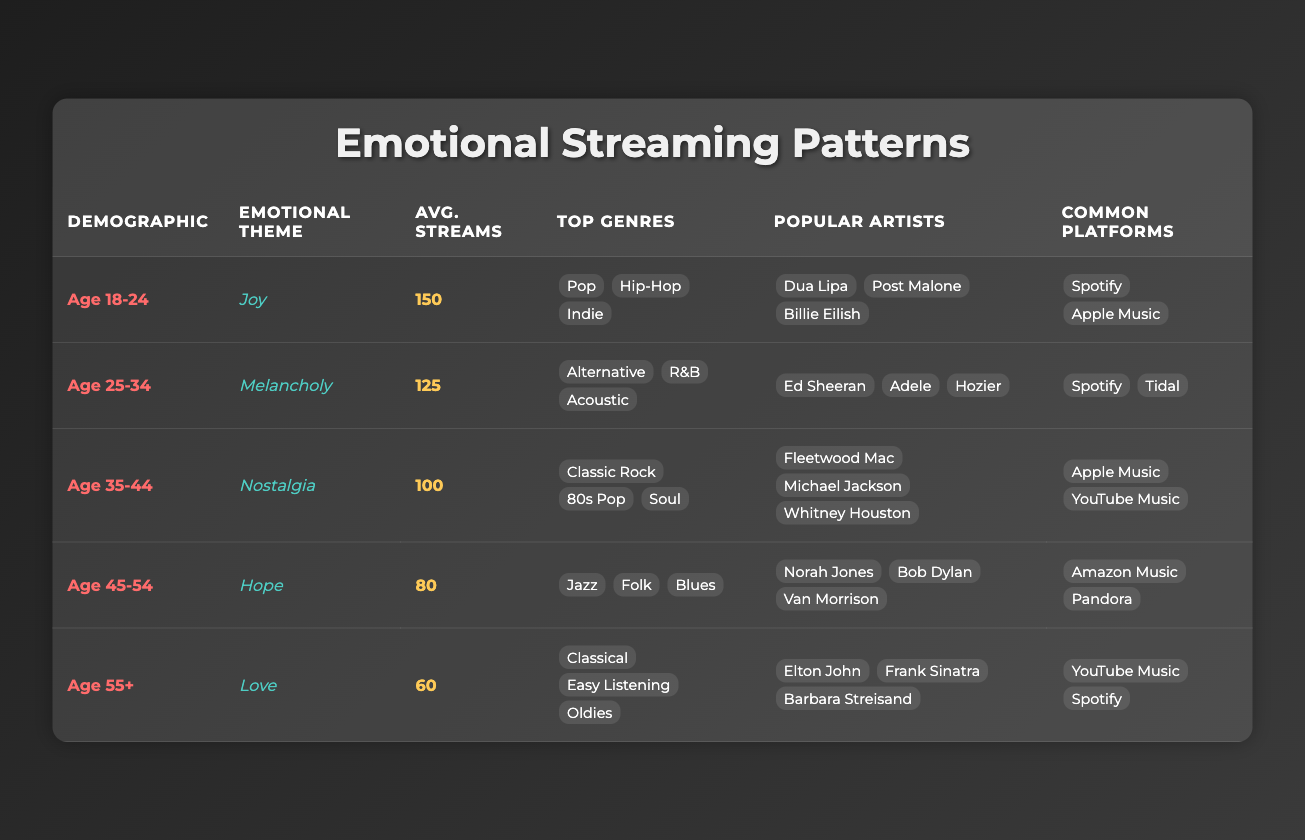What is the emotional theme for the Age 35-44 demographic group? The table clearly states that the emotional theme for the Age 35-44 demographic group is "Nostalgia."
Answer: Nostalgia Which demographic group has the highest average streams per user? By examining the averages listed in the table, the Age 18-24 demographic group has the highest average streams per user at 150.
Answer: Age 18-24 Is the top genre for the Age 45-54 demographic group Jazz? The table indicates that the top genres for this demographic group include Jazz, but there are also Folk and Blues listed. Hence, the answer is yes, as Jazz is one of the top genres.
Answer: Yes Calculate the average streams per user for all demographic groups combined. The average streams per user can be calculated by summing up the average streams from all groups: 150 + 125 + 100 + 80 + 60 = 615. There are 5 demographic groups, so the average is 615 / 5 = 123.
Answer: 123 Which emotional theme corresponds with Age 55+? The table specifies that the emotional theme for the Age 55+ demographic group is "Love."
Answer: Love Do the common platforms for Age 25-34 include Apple Music? The common platforms listed for Age 25-34 are Spotify and Tidal, which does not include Apple Music. Therefore, the answer is no.
Answer: No How many top genres are listed for the Age 18-24 demographic group? The table shows three top genres for the Age 18-24 demographic group: Pop, Hip-Hop, and Indie, making a total of three.
Answer: 3 Which demographic group has the emotional theme of Melancholy? By looking at the table, it states that the Age 25-34 demographic group is characterized by the emotional theme of Melancholy.
Answer: Age 25-34 What is the combined average streams per user for the Age 45-54 and Age 55+ demographics? The average streams per user for Age 45-54 is 80 and for Age 55+ is 60. Adding these together gives 80 + 60 = 140. Consequently, to find the average for both groups, we divide by 2: 140 / 2 = 70.
Answer: 70 Which demographic group prefers Classical music as a top genre? The table indicates that the top genre for the Age 55+ demographic group is Classical, confirming that this group prefers Classical music.
Answer: Age 55+ 